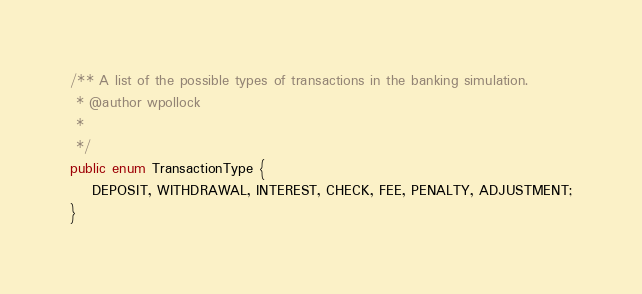Convert code to text. <code><loc_0><loc_0><loc_500><loc_500><_Java_>
/** A list of the possible types of transactions in the banking simulation.
 * @author wpollock
 *
 */
public enum TransactionType {
    DEPOSIT, WITHDRAWAL, INTEREST, CHECK, FEE, PENALTY, ADJUSTMENT;
}
</code> 